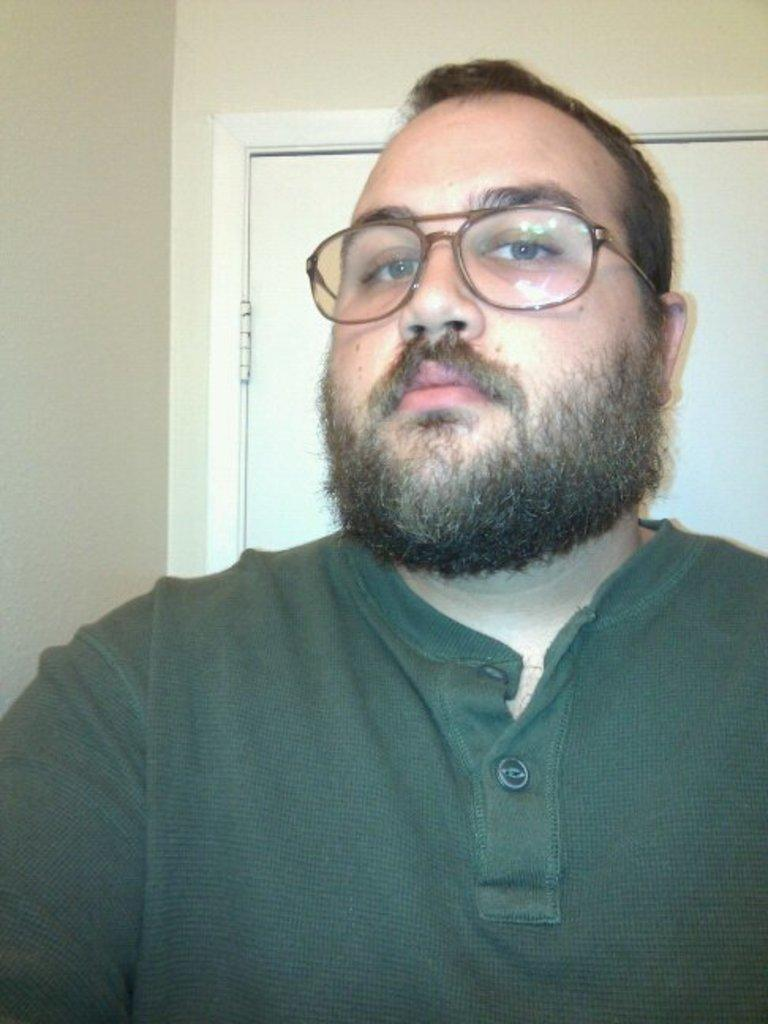Who is the main subject in the image? There is a man in the center of the image. What is located behind the man? There is a door behind the man. Is the man in the image talking to a representative about the rain? There is no indication in the image that the man is talking to a representative or discussing the rain. 